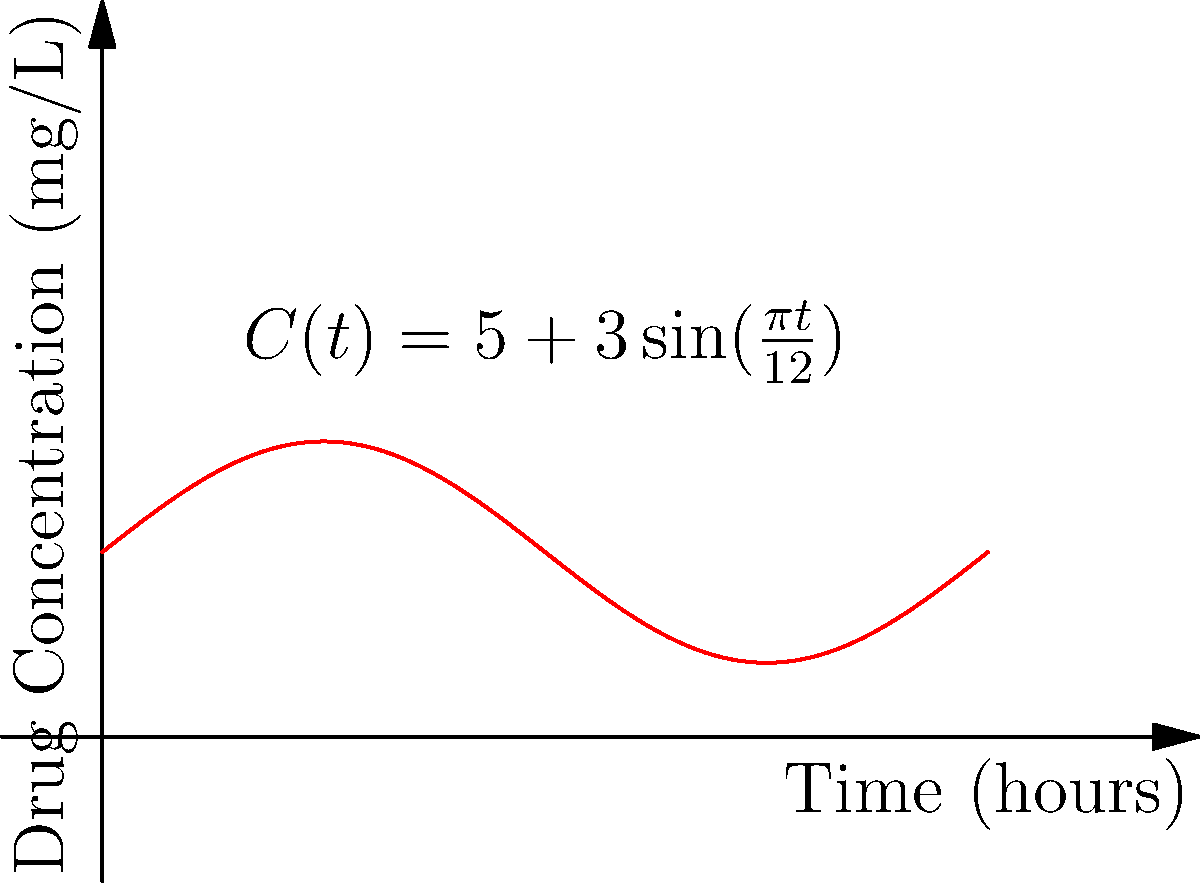A new drug's concentration in the bloodstream follows a periodic function $C(t) = 5 + 3\sin(\frac{\pi t}{12})$, where $C$ is the concentration in mg/L and $t$ is time in hours. What is the maximum rate of change of the drug concentration, and at what time(s) does this occur within the first 24-hour period? To find the maximum rate of change and when it occurs, we need to follow these steps:

1) First, we need to find the derivative of the concentration function:
   $C'(t) = \frac{d}{dt}[5 + 3\sin(\frac{\pi t}{12})]$
   $C'(t) = 3 \cdot \frac{\pi}{12} \cos(\frac{\pi t}{12}) = \frac{\pi}{4} \cos(\frac{\pi t}{12})$

2) The maximum rate of change will occur when $C'(t)$ is at its maximum value. Since cosine oscillates between -1 and 1, the maximum value of $C'(t)$ will be when $\cos(\frac{\pi t}{12}) = 1$.

3) The maximum value of $C'(t)$ is:
   $C'(t)_{max} = \frac{\pi}{4} \approx 0.7854$ mg/L per hour

4) To find when this occurs, we solve:
   $\cos(\frac{\pi t}{12}) = 1$

   This occurs when $\frac{\pi t}{12} = 2\pi n$, where n is an integer.

5) Solving for t:
   $t = 24n$ hours

6) Within the first 24-hour period (0 ≤ t < 24), this occurs when n = 0, so at t = 0 hours.

Therefore, the maximum rate of change is $\frac{\pi}{4}$ mg/L per hour, occurring at 0 hours (and every 24 hours thereafter).
Answer: $\frac{\pi}{4}$ mg/L per hour, at t = 0 hours 